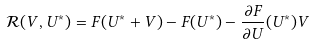<formula> <loc_0><loc_0><loc_500><loc_500>\mathcal { R } ( V , U ^ { * } ) = F ( U ^ { * } + V ) - F ( U ^ { * } ) - \frac { \partial F } { \partial U } ( U ^ { * } ) V</formula> 